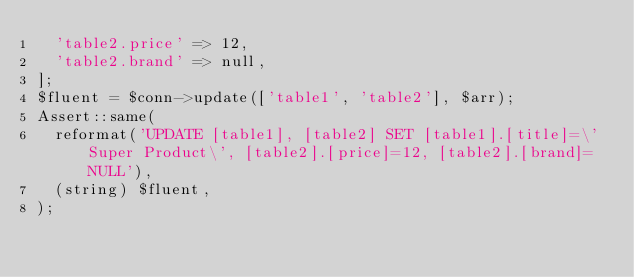Convert code to text. <code><loc_0><loc_0><loc_500><loc_500><_PHP_>	'table2.price' => 12,
	'table2.brand' => null,
];
$fluent = $conn->update(['table1', 'table2'], $arr);
Assert::same(
	reformat('UPDATE [table1], [table2] SET [table1].[title]=\'Super Product\', [table2].[price]=12, [table2].[brand]=NULL'),
	(string) $fluent,
);
</code> 